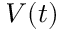Convert formula to latex. <formula><loc_0><loc_0><loc_500><loc_500>V ( t )</formula> 